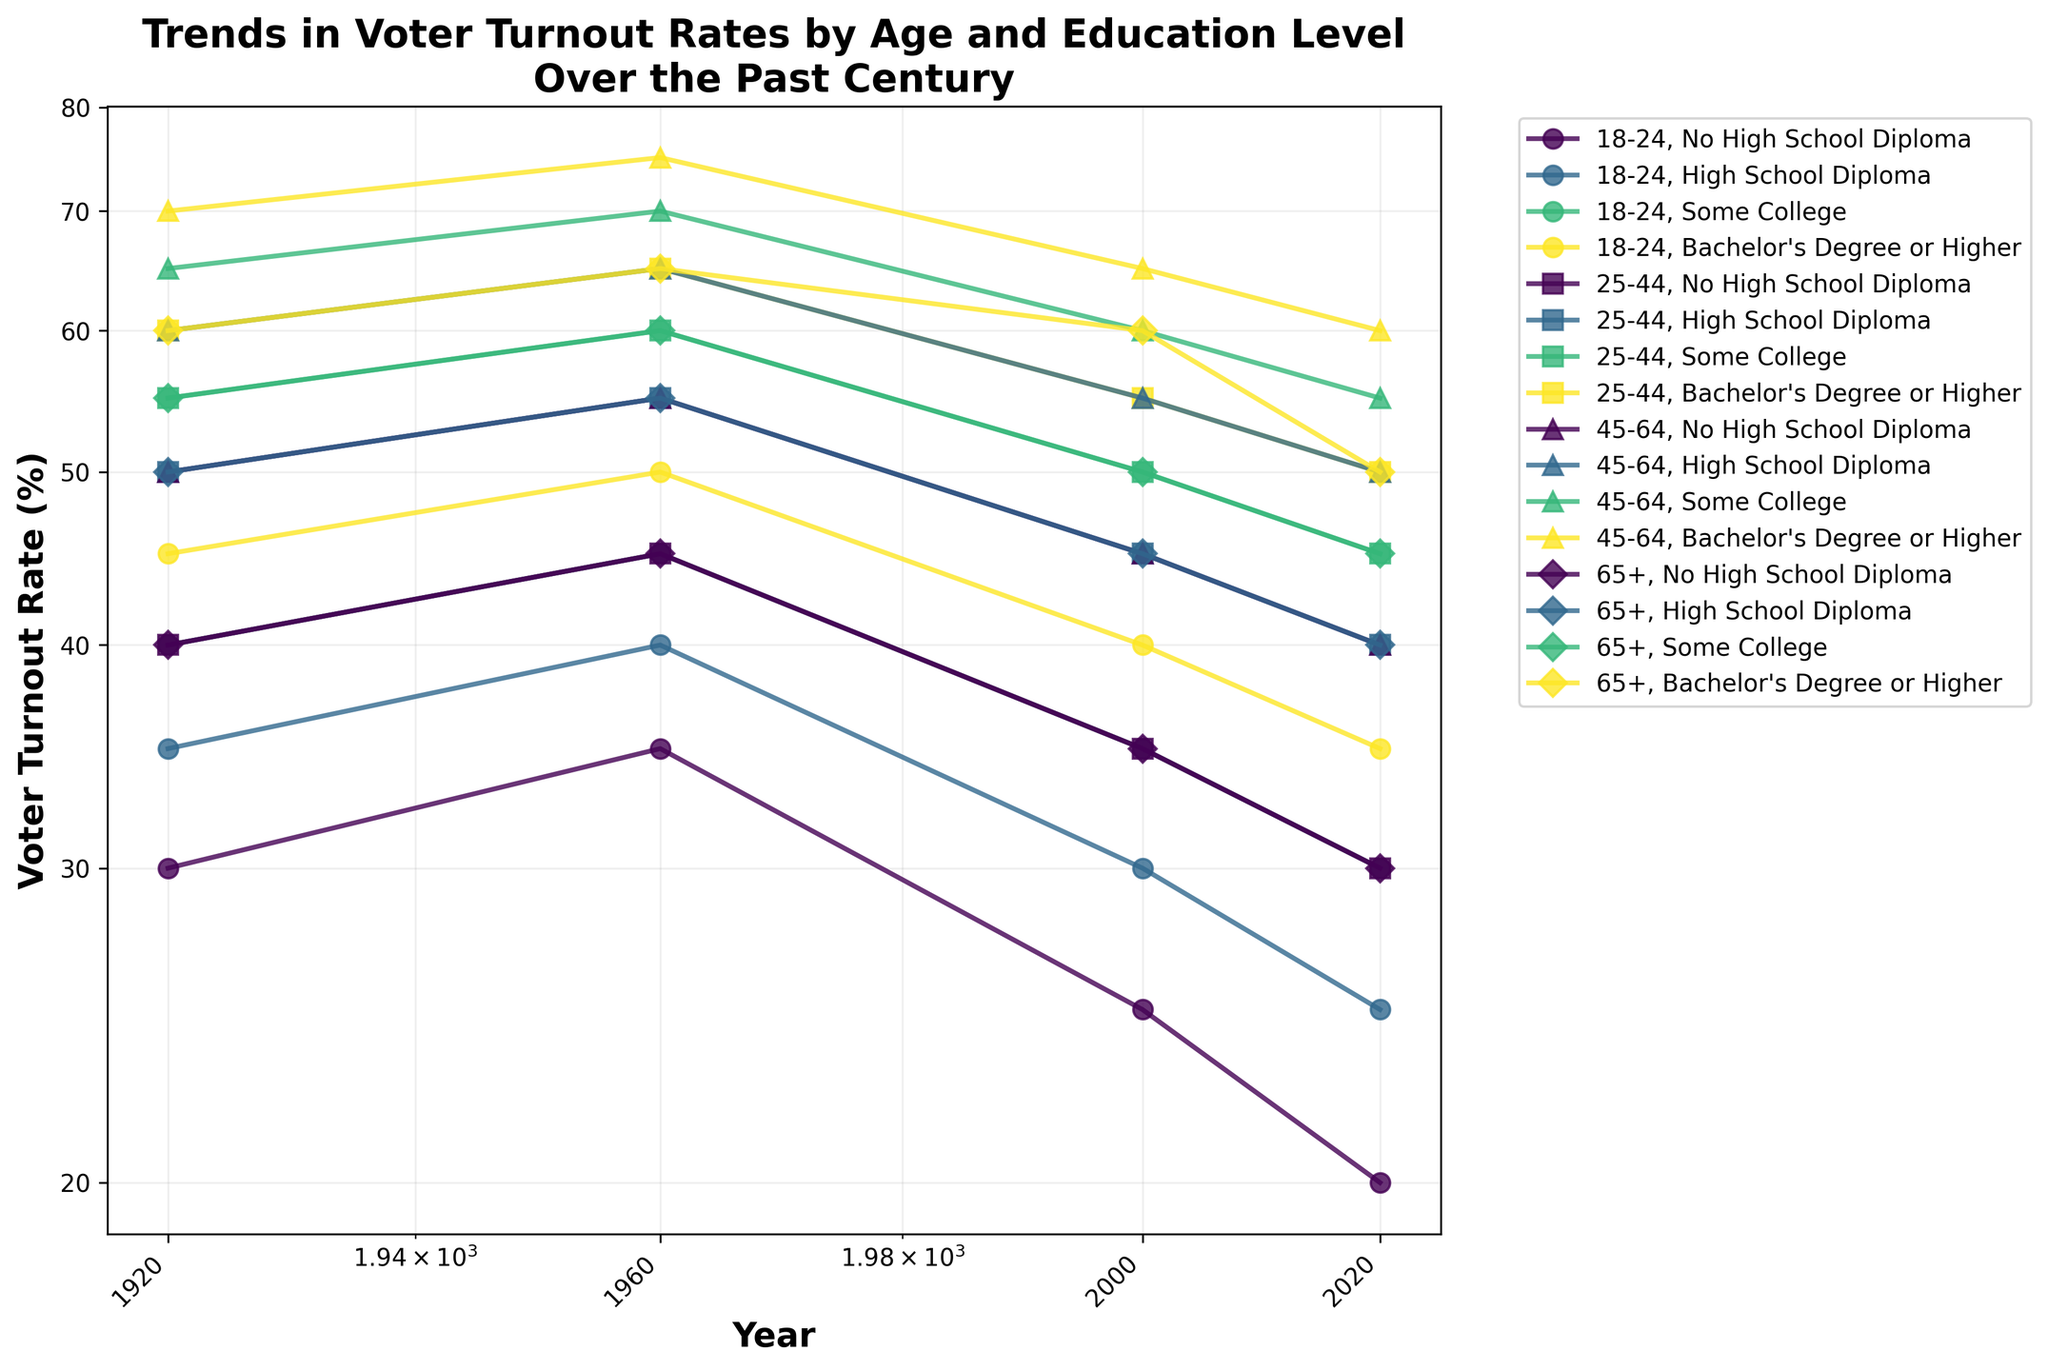what is the title of the figure? The title of a figure is usually displayed at the top, summarizing its content. Here, it reads "Trends in Voter Turnout Rates by Age and Education Level Over the Past Century," indicating the key focus of the presented data.
Answer: Trends in Voter Turnout Rates by Age and Education Level Over the Past Century How does voter turnout rate for 18-24 age group with no high school diploma change from 1920 to 2020? To find this, locate the line corresponding to the 18-24 age group and no high school diploma. Check the voter turnout rates at the starting and ending years (1920 and 2020). In 1920, it starts at 30%, and in 2020, it's 20%.
Answer: Decreases from 30% to 20% Which education level showed the greatest decrease in voter turnout rate for the 65+ age group from 1920 to 2020? Examine the lines for the 65+ age group across different education levels. Compare the changes from 1920 to 2020. The line for 'Some College' drops from 55% to 45%, the largest decrease among the education levels.
Answer: Some College In which year was the voter turnout rate highest for the 45-64 age group with a bachelor's degree or higher? Follow the line for the 45-64 age group with a bachelor's degree or higher across the years. The highest voter turnout rate is in 1960, at 75%.
Answer: 1960 What is the trend in voter turnout rate for the 25-44 age group with a high school diploma from 1960 to 2020? Identify the line for the 25-44 age group with a high school diploma from 1960 to 2020. The trend shows a decrease, from 55% in 1960 to 40% in 2020.
Answer: Decreasing How do the voter turnout rates for the 25-44 age group with some college compare between 1960 and 2000? Locate the line for the 25-44 age group with some college and compare the values in 1960 and 2000. In 1960, the rate is 60%, and in 2000, it's 50%, showing a decrease over time.
Answer: Decrease from 60% to 50% Which age group showed an increase in voter turnout rate for no high school diploma between 1920 and 1960? Compare the lines for each age group with no high school diploma between 1920 and 1960. Both 18-24 and 65+ show increases. 18-24 increases from 30% to 35%, and 65+ increases from 40% to 45%.
Answer: 18-24 and 65+ What are the voter turnout rates for 45-64 age group with a Bachelor's degree or higher in 1920 and 2020? Look at the line for the 45-64 age group with a Bachelor's degree or higher and compare the rates in 1920 and 2020. In 1920, it is 70%; in 2020, it is 60%.
Answer: 70% and 60% When did the voter turnout rate for the 18-24 age group with a high school diploma peak? Trace the line for the 18-24 age group with a high school diploma to identify the highest point. The peak occurs in 1960, with a rate of 40%.
Answer: 1960 Which age group and education level saw the most consistent decline in voter turnout rates over the years? Review all lines across age groups and education levels for consistent trends. The 18-24 age group with no high school diploma shows a steady decline from 30% in 1920 to 20% in 2020.
Answer: 18-24 with no high school diploma 